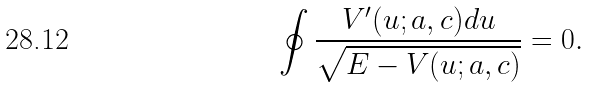<formula> <loc_0><loc_0><loc_500><loc_500>\oint \frac { V ^ { \prime } ( u ; a , c ) d u } { \sqrt { E - V ( u ; a , c ) } } = 0 .</formula> 